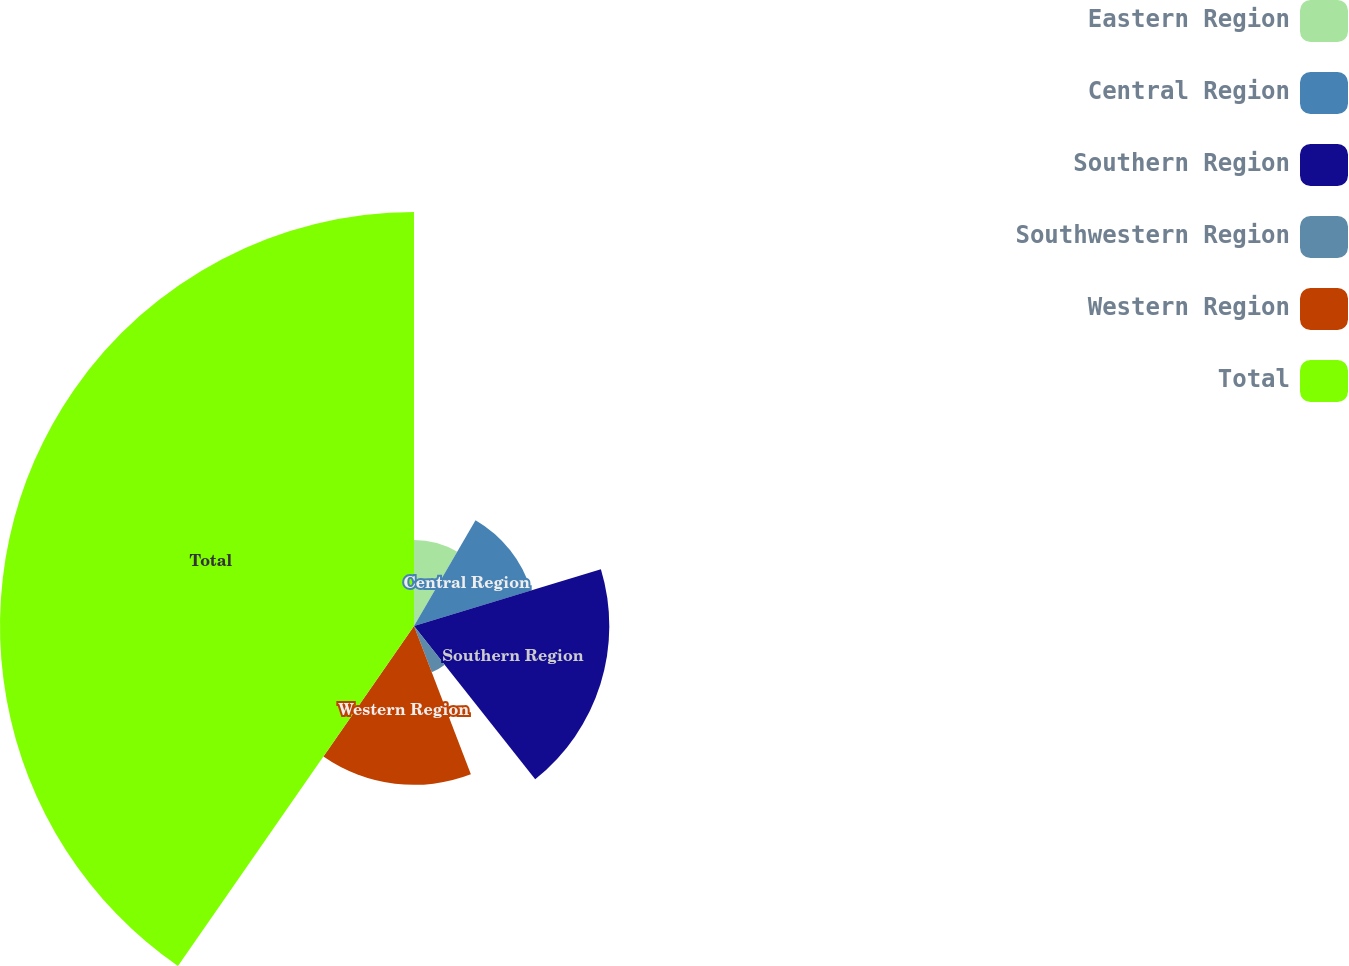Convert chart. <chart><loc_0><loc_0><loc_500><loc_500><pie_chart><fcel>Eastern Region<fcel>Central Region<fcel>Southern Region<fcel>Southwestern Region<fcel>Western Region<fcel>Total<nl><fcel>8.38%<fcel>11.93%<fcel>19.03%<fcel>4.83%<fcel>15.48%<fcel>40.34%<nl></chart> 